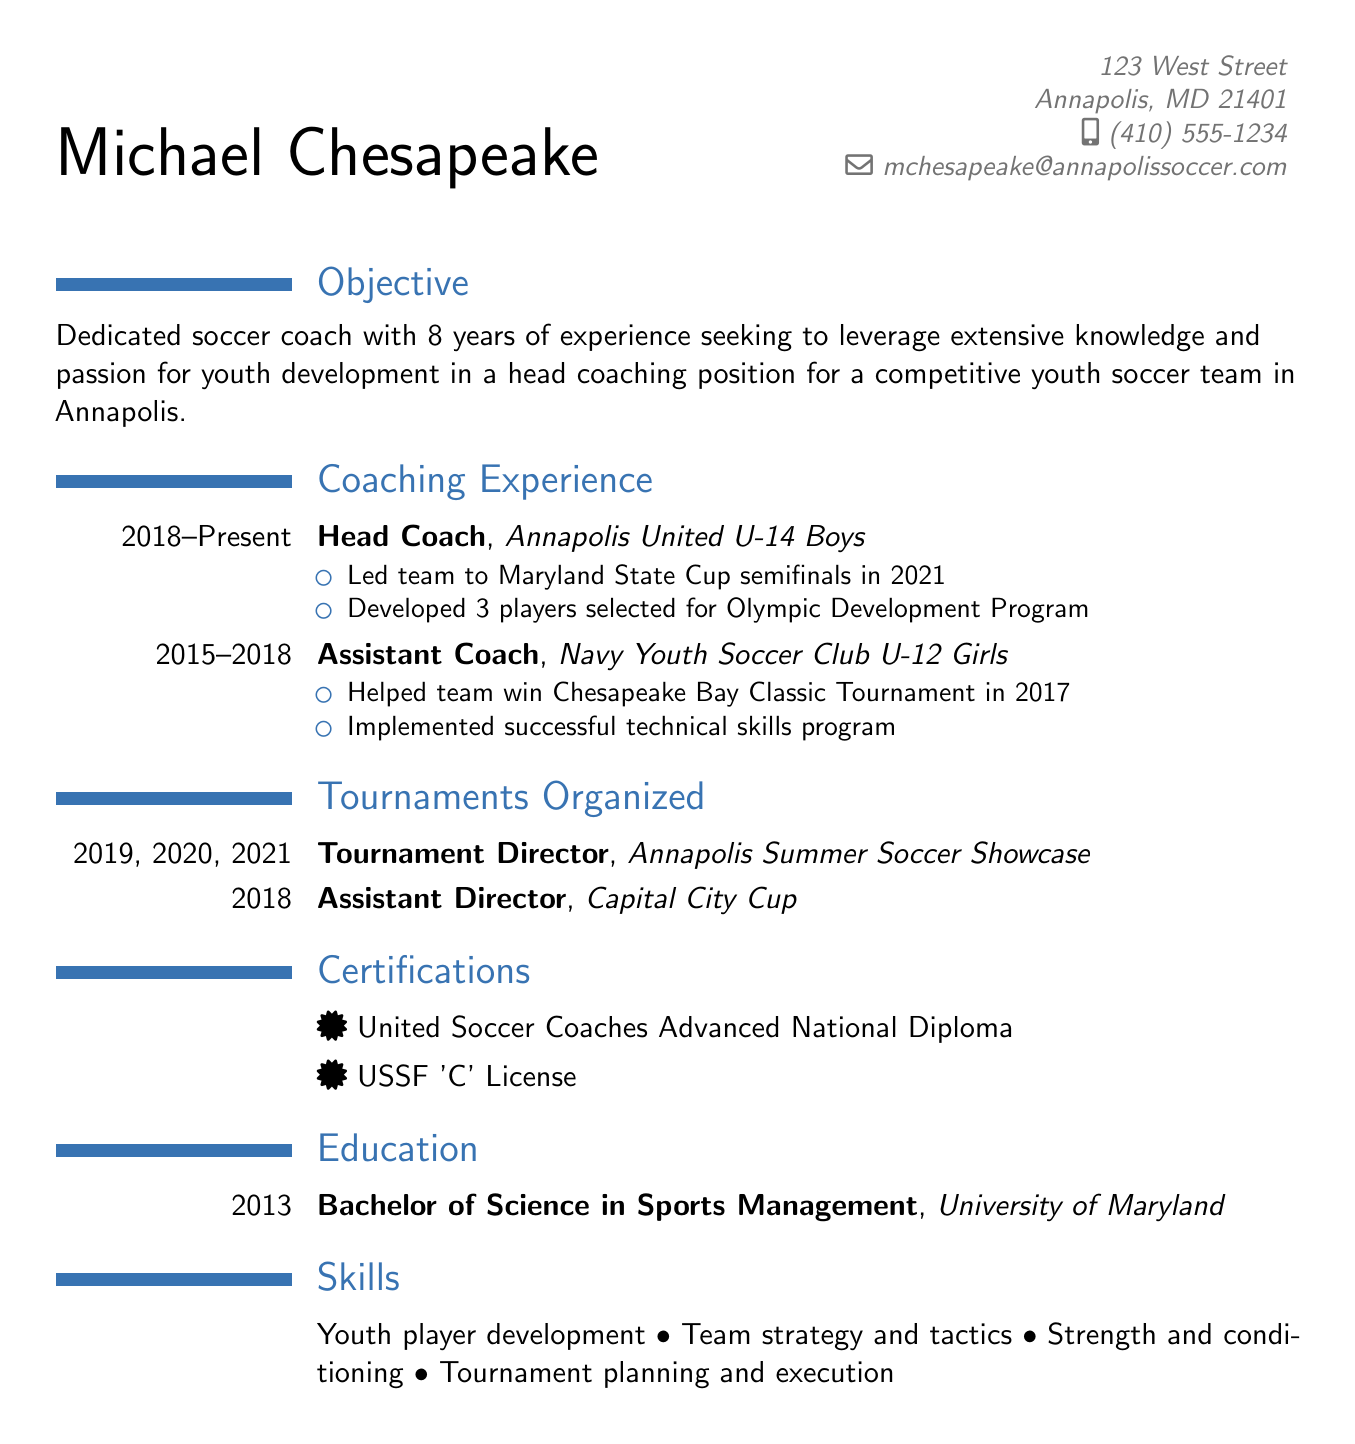What is the name of the coach? The name of the coach is mentioned in the personal info section of the document.
Answer: Michael Chesapeake What is the current position held by Michael Chesapeake? The current position is listed under the coaching experience section of the document.
Answer: Head Coach What team does Michael coach? The team is specified in the coaching experience section of the document.
Answer: Annapolis United U-14 Boys During which years did he assist the Navy Youth Soccer Club? The duration can be found in the coaching experience section, indicating when he served in that role.
Answer: 2015 - 2018 What achievement did Michael have with the U-14 Boys team in 2021? This specific accomplishment is highlighted in the achievements section of the coaching experience.
Answer: Led team to Maryland State Cup semifinals How many tournaments did Michael organize as Tournament Director? The number of tournaments organized is indicated in the tournaments organized section of the document.
Answer: 3 What certification does he hold related to United Soccer Coaches? The certifications section lists the relevant qualifications he possesses.
Answer: United Soccer Coaches Advanced National Diploma In what year did he earn his degree? The year of the degree is specified in the education section of the document.
Answer: 2013 What is one of the skills listed in the CV? The skills section provides several competencies he has, and one can be extracted from that.
Answer: Youth player development 